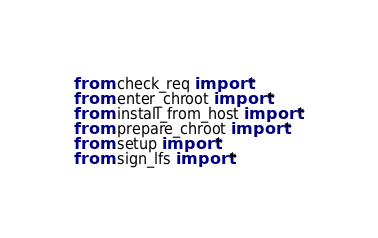<code> <loc_0><loc_0><loc_500><loc_500><_Python_>from .check_req import *
from .enter_chroot import *
from .install_from_host import *
from .prepare_chroot import *
from .setup import *
from .sign_lfs import *
</code> 